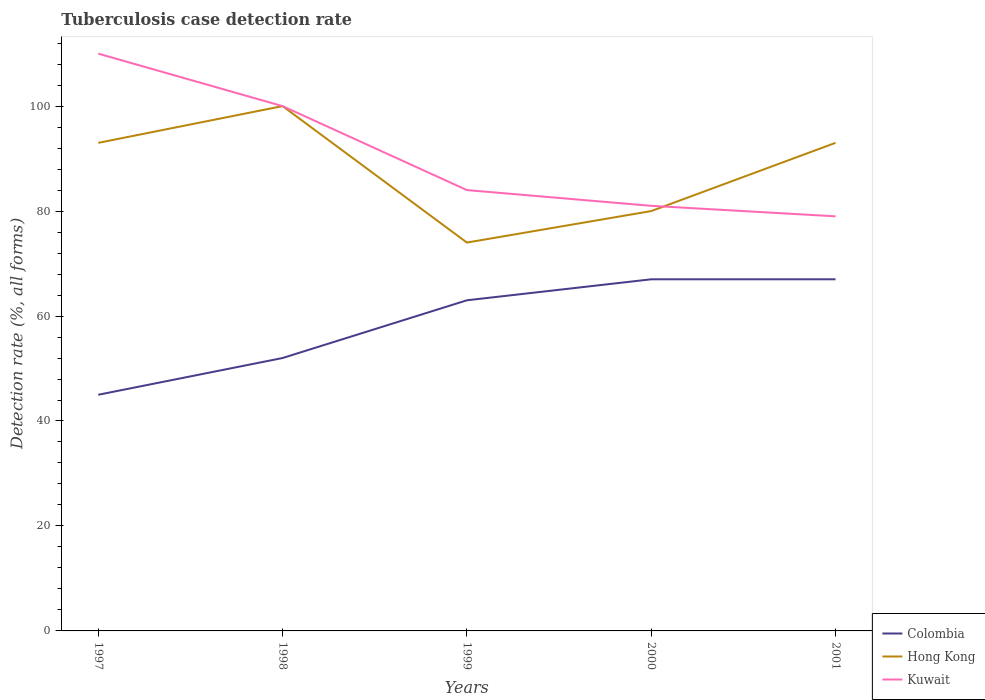Across all years, what is the maximum tuberculosis case detection rate in in Hong Kong?
Make the answer very short. 74. In which year was the tuberculosis case detection rate in in Hong Kong maximum?
Your answer should be compact. 1999. What is the total tuberculosis case detection rate in in Colombia in the graph?
Provide a succinct answer. -18. What is the difference between the highest and the second highest tuberculosis case detection rate in in Hong Kong?
Ensure brevity in your answer.  26. How many lines are there?
Make the answer very short. 3. What is the difference between two consecutive major ticks on the Y-axis?
Provide a short and direct response. 20. Are the values on the major ticks of Y-axis written in scientific E-notation?
Provide a short and direct response. No. Does the graph contain grids?
Give a very brief answer. No. How are the legend labels stacked?
Give a very brief answer. Vertical. What is the title of the graph?
Your answer should be very brief. Tuberculosis case detection rate. Does "Hungary" appear as one of the legend labels in the graph?
Provide a succinct answer. No. What is the label or title of the Y-axis?
Offer a very short reply. Detection rate (%, all forms). What is the Detection rate (%, all forms) of Colombia in 1997?
Make the answer very short. 45. What is the Detection rate (%, all forms) of Hong Kong in 1997?
Your answer should be compact. 93. What is the Detection rate (%, all forms) of Kuwait in 1997?
Your response must be concise. 110. What is the Detection rate (%, all forms) of Colombia in 1998?
Make the answer very short. 52. What is the Detection rate (%, all forms) of Hong Kong in 1998?
Offer a very short reply. 100. What is the Detection rate (%, all forms) in Colombia in 1999?
Offer a terse response. 63. What is the Detection rate (%, all forms) of Hong Kong in 1999?
Keep it short and to the point. 74. What is the Detection rate (%, all forms) of Colombia in 2000?
Provide a short and direct response. 67. What is the Detection rate (%, all forms) of Hong Kong in 2000?
Provide a succinct answer. 80. What is the Detection rate (%, all forms) of Colombia in 2001?
Keep it short and to the point. 67. What is the Detection rate (%, all forms) in Hong Kong in 2001?
Your answer should be compact. 93. What is the Detection rate (%, all forms) of Kuwait in 2001?
Your answer should be compact. 79. Across all years, what is the maximum Detection rate (%, all forms) in Kuwait?
Ensure brevity in your answer.  110. Across all years, what is the minimum Detection rate (%, all forms) of Colombia?
Keep it short and to the point. 45. Across all years, what is the minimum Detection rate (%, all forms) in Hong Kong?
Provide a short and direct response. 74. Across all years, what is the minimum Detection rate (%, all forms) of Kuwait?
Ensure brevity in your answer.  79. What is the total Detection rate (%, all forms) of Colombia in the graph?
Your response must be concise. 294. What is the total Detection rate (%, all forms) of Hong Kong in the graph?
Your answer should be compact. 440. What is the total Detection rate (%, all forms) in Kuwait in the graph?
Make the answer very short. 454. What is the difference between the Detection rate (%, all forms) in Hong Kong in 1997 and that in 1999?
Offer a very short reply. 19. What is the difference between the Detection rate (%, all forms) in Kuwait in 1997 and that in 1999?
Provide a succinct answer. 26. What is the difference between the Detection rate (%, all forms) of Hong Kong in 1997 and that in 2000?
Your response must be concise. 13. What is the difference between the Detection rate (%, all forms) of Colombia in 1997 and that in 2001?
Your answer should be compact. -22. What is the difference between the Detection rate (%, all forms) of Colombia in 1998 and that in 2000?
Make the answer very short. -15. What is the difference between the Detection rate (%, all forms) of Hong Kong in 1998 and that in 2000?
Make the answer very short. 20. What is the difference between the Detection rate (%, all forms) in Colombia in 1998 and that in 2001?
Your answer should be very brief. -15. What is the difference between the Detection rate (%, all forms) in Hong Kong in 1998 and that in 2001?
Ensure brevity in your answer.  7. What is the difference between the Detection rate (%, all forms) in Kuwait in 1998 and that in 2001?
Offer a very short reply. 21. What is the difference between the Detection rate (%, all forms) of Colombia in 1999 and that in 2000?
Your response must be concise. -4. What is the difference between the Detection rate (%, all forms) in Hong Kong in 1999 and that in 2000?
Provide a short and direct response. -6. What is the difference between the Detection rate (%, all forms) of Kuwait in 1999 and that in 2000?
Make the answer very short. 3. What is the difference between the Detection rate (%, all forms) of Hong Kong in 1999 and that in 2001?
Provide a short and direct response. -19. What is the difference between the Detection rate (%, all forms) of Hong Kong in 2000 and that in 2001?
Your response must be concise. -13. What is the difference between the Detection rate (%, all forms) in Colombia in 1997 and the Detection rate (%, all forms) in Hong Kong in 1998?
Your answer should be compact. -55. What is the difference between the Detection rate (%, all forms) in Colombia in 1997 and the Detection rate (%, all forms) in Kuwait in 1998?
Offer a very short reply. -55. What is the difference between the Detection rate (%, all forms) of Hong Kong in 1997 and the Detection rate (%, all forms) of Kuwait in 1998?
Offer a very short reply. -7. What is the difference between the Detection rate (%, all forms) in Colombia in 1997 and the Detection rate (%, all forms) in Kuwait in 1999?
Make the answer very short. -39. What is the difference between the Detection rate (%, all forms) in Colombia in 1997 and the Detection rate (%, all forms) in Hong Kong in 2000?
Provide a short and direct response. -35. What is the difference between the Detection rate (%, all forms) in Colombia in 1997 and the Detection rate (%, all forms) in Kuwait in 2000?
Keep it short and to the point. -36. What is the difference between the Detection rate (%, all forms) in Hong Kong in 1997 and the Detection rate (%, all forms) in Kuwait in 2000?
Offer a very short reply. 12. What is the difference between the Detection rate (%, all forms) in Colombia in 1997 and the Detection rate (%, all forms) in Hong Kong in 2001?
Ensure brevity in your answer.  -48. What is the difference between the Detection rate (%, all forms) of Colombia in 1997 and the Detection rate (%, all forms) of Kuwait in 2001?
Offer a very short reply. -34. What is the difference between the Detection rate (%, all forms) in Hong Kong in 1997 and the Detection rate (%, all forms) in Kuwait in 2001?
Make the answer very short. 14. What is the difference between the Detection rate (%, all forms) of Colombia in 1998 and the Detection rate (%, all forms) of Kuwait in 1999?
Provide a succinct answer. -32. What is the difference between the Detection rate (%, all forms) in Colombia in 1998 and the Detection rate (%, all forms) in Hong Kong in 2000?
Offer a terse response. -28. What is the difference between the Detection rate (%, all forms) of Colombia in 1998 and the Detection rate (%, all forms) of Kuwait in 2000?
Ensure brevity in your answer.  -29. What is the difference between the Detection rate (%, all forms) in Hong Kong in 1998 and the Detection rate (%, all forms) in Kuwait in 2000?
Your answer should be compact. 19. What is the difference between the Detection rate (%, all forms) in Colombia in 1998 and the Detection rate (%, all forms) in Hong Kong in 2001?
Provide a short and direct response. -41. What is the difference between the Detection rate (%, all forms) of Colombia in 1998 and the Detection rate (%, all forms) of Kuwait in 2001?
Give a very brief answer. -27. What is the difference between the Detection rate (%, all forms) in Hong Kong in 1998 and the Detection rate (%, all forms) in Kuwait in 2001?
Your response must be concise. 21. What is the difference between the Detection rate (%, all forms) of Colombia in 1999 and the Detection rate (%, all forms) of Hong Kong in 2000?
Keep it short and to the point. -17. What is the difference between the Detection rate (%, all forms) of Colombia in 1999 and the Detection rate (%, all forms) of Kuwait in 2001?
Offer a very short reply. -16. What is the difference between the Detection rate (%, all forms) in Hong Kong in 2000 and the Detection rate (%, all forms) in Kuwait in 2001?
Offer a very short reply. 1. What is the average Detection rate (%, all forms) of Colombia per year?
Offer a terse response. 58.8. What is the average Detection rate (%, all forms) in Kuwait per year?
Your response must be concise. 90.8. In the year 1997, what is the difference between the Detection rate (%, all forms) of Colombia and Detection rate (%, all forms) of Hong Kong?
Keep it short and to the point. -48. In the year 1997, what is the difference between the Detection rate (%, all forms) of Colombia and Detection rate (%, all forms) of Kuwait?
Make the answer very short. -65. In the year 1998, what is the difference between the Detection rate (%, all forms) in Colombia and Detection rate (%, all forms) in Hong Kong?
Make the answer very short. -48. In the year 1998, what is the difference between the Detection rate (%, all forms) of Colombia and Detection rate (%, all forms) of Kuwait?
Your response must be concise. -48. In the year 1999, what is the difference between the Detection rate (%, all forms) in Colombia and Detection rate (%, all forms) in Hong Kong?
Keep it short and to the point. -11. In the year 2000, what is the difference between the Detection rate (%, all forms) of Colombia and Detection rate (%, all forms) of Hong Kong?
Ensure brevity in your answer.  -13. In the year 2000, what is the difference between the Detection rate (%, all forms) in Hong Kong and Detection rate (%, all forms) in Kuwait?
Your answer should be compact. -1. In the year 2001, what is the difference between the Detection rate (%, all forms) of Hong Kong and Detection rate (%, all forms) of Kuwait?
Your answer should be very brief. 14. What is the ratio of the Detection rate (%, all forms) in Colombia in 1997 to that in 1998?
Make the answer very short. 0.87. What is the ratio of the Detection rate (%, all forms) in Kuwait in 1997 to that in 1998?
Your response must be concise. 1.1. What is the ratio of the Detection rate (%, all forms) of Hong Kong in 1997 to that in 1999?
Make the answer very short. 1.26. What is the ratio of the Detection rate (%, all forms) in Kuwait in 1997 to that in 1999?
Make the answer very short. 1.31. What is the ratio of the Detection rate (%, all forms) of Colombia in 1997 to that in 2000?
Provide a succinct answer. 0.67. What is the ratio of the Detection rate (%, all forms) of Hong Kong in 1997 to that in 2000?
Your answer should be very brief. 1.16. What is the ratio of the Detection rate (%, all forms) in Kuwait in 1997 to that in 2000?
Make the answer very short. 1.36. What is the ratio of the Detection rate (%, all forms) of Colombia in 1997 to that in 2001?
Your answer should be compact. 0.67. What is the ratio of the Detection rate (%, all forms) of Hong Kong in 1997 to that in 2001?
Make the answer very short. 1. What is the ratio of the Detection rate (%, all forms) of Kuwait in 1997 to that in 2001?
Provide a succinct answer. 1.39. What is the ratio of the Detection rate (%, all forms) in Colombia in 1998 to that in 1999?
Keep it short and to the point. 0.83. What is the ratio of the Detection rate (%, all forms) in Hong Kong in 1998 to that in 1999?
Provide a short and direct response. 1.35. What is the ratio of the Detection rate (%, all forms) in Kuwait in 1998 to that in 1999?
Provide a short and direct response. 1.19. What is the ratio of the Detection rate (%, all forms) in Colombia in 1998 to that in 2000?
Ensure brevity in your answer.  0.78. What is the ratio of the Detection rate (%, all forms) in Hong Kong in 1998 to that in 2000?
Your response must be concise. 1.25. What is the ratio of the Detection rate (%, all forms) of Kuwait in 1998 to that in 2000?
Provide a succinct answer. 1.23. What is the ratio of the Detection rate (%, all forms) in Colombia in 1998 to that in 2001?
Give a very brief answer. 0.78. What is the ratio of the Detection rate (%, all forms) of Hong Kong in 1998 to that in 2001?
Your answer should be compact. 1.08. What is the ratio of the Detection rate (%, all forms) in Kuwait in 1998 to that in 2001?
Offer a very short reply. 1.27. What is the ratio of the Detection rate (%, all forms) of Colombia in 1999 to that in 2000?
Your answer should be very brief. 0.94. What is the ratio of the Detection rate (%, all forms) of Hong Kong in 1999 to that in 2000?
Give a very brief answer. 0.93. What is the ratio of the Detection rate (%, all forms) of Colombia in 1999 to that in 2001?
Your answer should be very brief. 0.94. What is the ratio of the Detection rate (%, all forms) of Hong Kong in 1999 to that in 2001?
Keep it short and to the point. 0.8. What is the ratio of the Detection rate (%, all forms) in Kuwait in 1999 to that in 2001?
Provide a short and direct response. 1.06. What is the ratio of the Detection rate (%, all forms) in Hong Kong in 2000 to that in 2001?
Offer a terse response. 0.86. What is the ratio of the Detection rate (%, all forms) of Kuwait in 2000 to that in 2001?
Offer a very short reply. 1.03. What is the difference between the highest and the second highest Detection rate (%, all forms) in Colombia?
Keep it short and to the point. 0. What is the difference between the highest and the second highest Detection rate (%, all forms) in Kuwait?
Give a very brief answer. 10. What is the difference between the highest and the lowest Detection rate (%, all forms) in Colombia?
Keep it short and to the point. 22. 